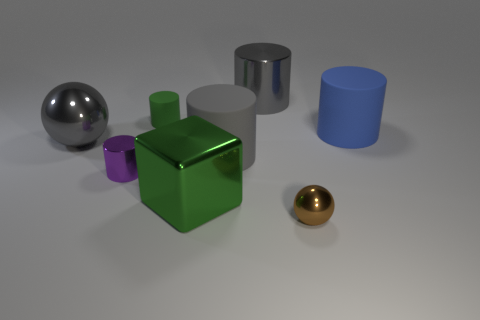What color is the big block that is made of the same material as the brown sphere?
Ensure brevity in your answer.  Green. What number of small spheres have the same material as the large green thing?
Keep it short and to the point. 1. There is a big shiny thing that is on the right side of the green block; is it the same color as the big metal sphere?
Make the answer very short. Yes. How many other big gray objects have the same shape as the gray matte object?
Offer a very short reply. 1. Are there an equal number of large objects to the right of the small brown shiny thing and green rubber objects?
Offer a very short reply. Yes. There is a matte cylinder that is the same size as the brown ball; what is its color?
Your response must be concise. Green. Are there any tiny cyan matte objects of the same shape as the large gray rubber thing?
Your response must be concise. No. There is a blue thing that is to the right of the large metal thing behind the large metal thing that is left of the green shiny cube; what is it made of?
Give a very brief answer. Rubber. What number of other things are the same size as the green matte cylinder?
Your response must be concise. 2. The small shiny cylinder has what color?
Offer a very short reply. Purple. 